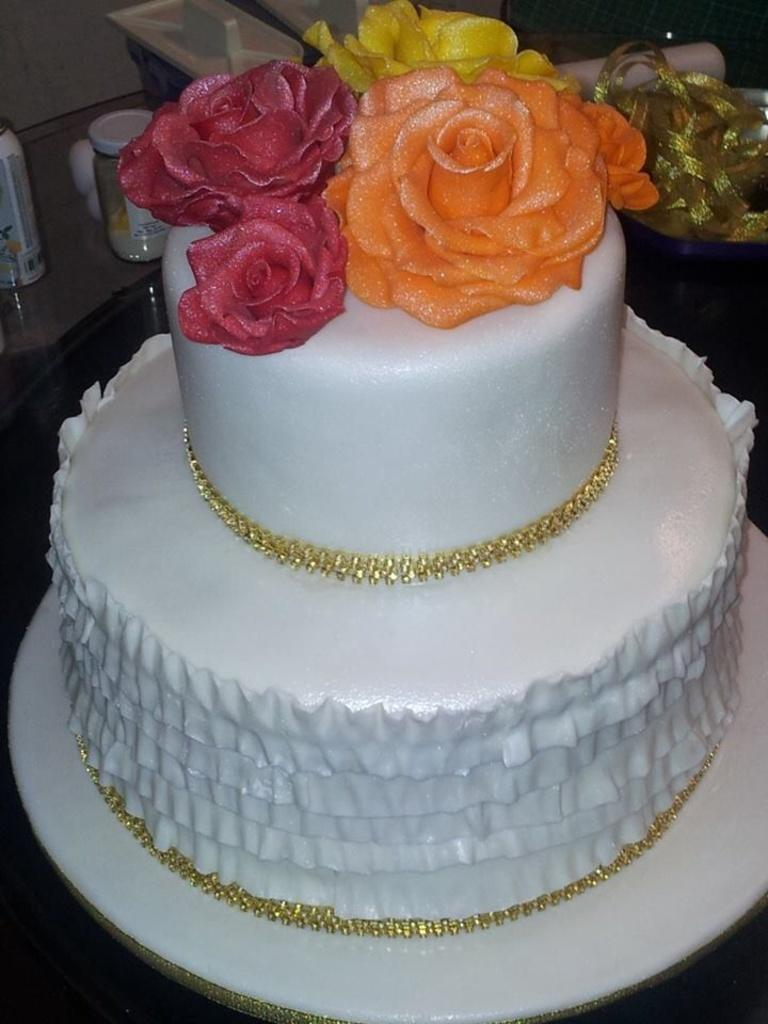What is the main subject of the image? There is a cake in the image. Can you describe any other objects present in the image? There are some other objects in the image, but their specific details are not mentioned in the provided facts. How many houses can be seen near the dock in the image? There are no houses or docks mentioned in the provided facts, so we cannot answer this question. 